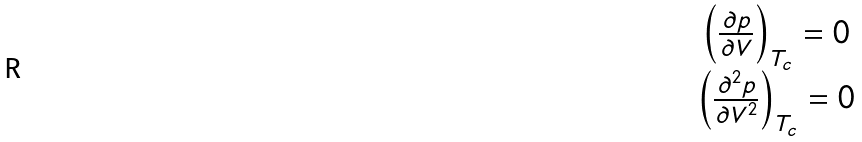<formula> <loc_0><loc_0><loc_500><loc_500>\begin{array} { c } \left ( \frac { \partial p } { \partial V } \right ) _ { T _ { c } } = 0 \\ \left ( \frac { \partial ^ { 2 } p } { \partial V ^ { 2 } } \right ) _ { T _ { c } } = 0 \end{array}</formula> 